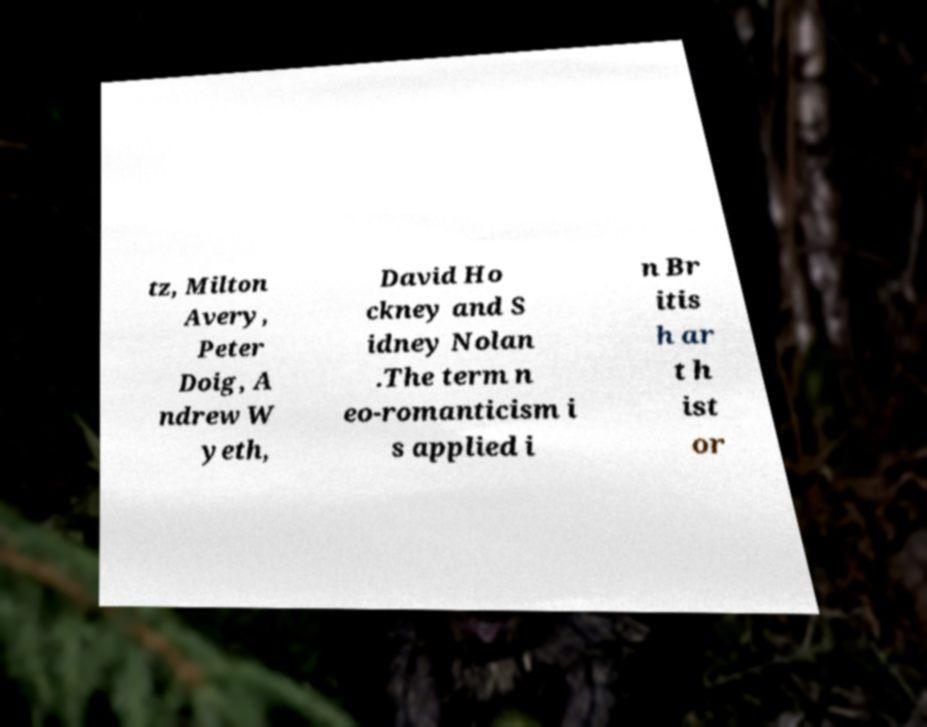There's text embedded in this image that I need extracted. Can you transcribe it verbatim? tz, Milton Avery, Peter Doig, A ndrew W yeth, David Ho ckney and S idney Nolan .The term n eo-romanticism i s applied i n Br itis h ar t h ist or 